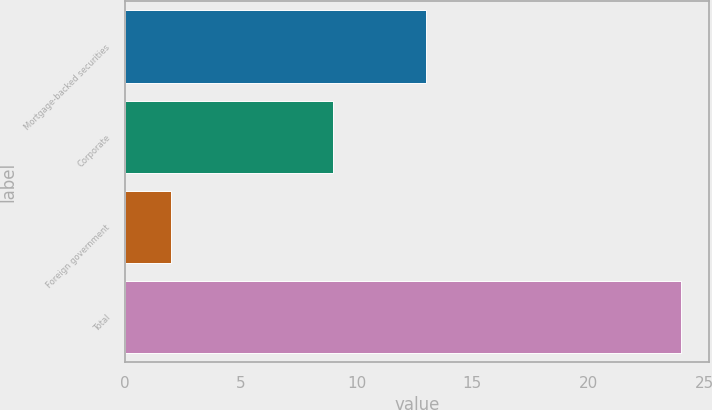Convert chart. <chart><loc_0><loc_0><loc_500><loc_500><bar_chart><fcel>Mortgage-backed securities<fcel>Corporate<fcel>Foreign government<fcel>Total<nl><fcel>13<fcel>9<fcel>2<fcel>24<nl></chart> 